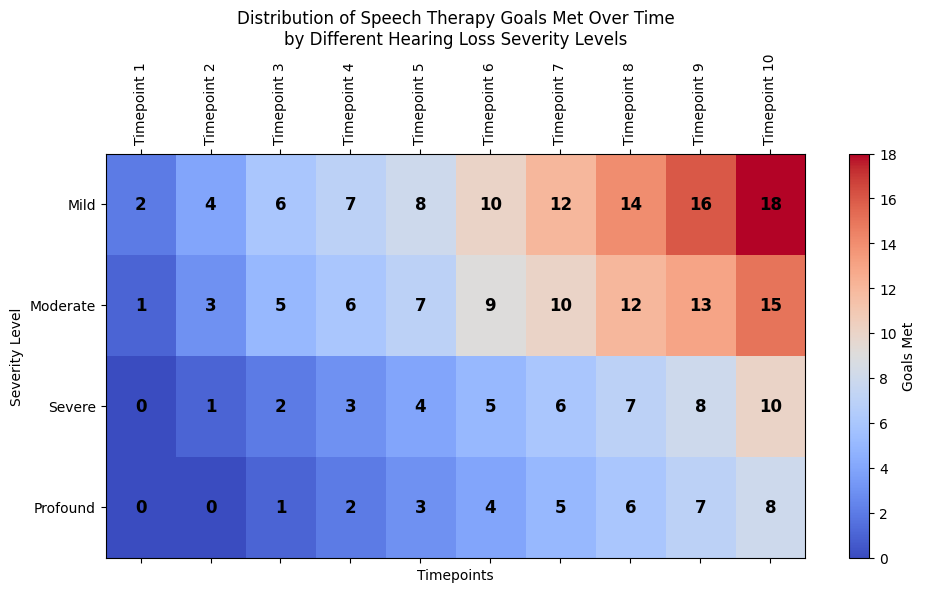What severity level has the most goals met at Timepoint 10? At Timepoint 10, checking the values for all severity levels shows Mild (18), Moderate (15), Severe (10), and Profound (8). Since 18 is the highest, Mild has the most goals met at Timepoint 10.
Answer: Mild Which severity level has the least goals met at Timepoint 3? For Timepoint 3, the values are Mild (6), Moderate (5), Severe (2), and Profound (1). Since 1 is the lowest, Profound has the least goals met at Timepoint 3.
Answer: Profound What is the average number of goals met by the Moderate severity level across all timepoints? Adding up the values for Moderate severity level: 1 + 3 + 5 + 6 + 7 + 9 + 10 + 12 + 13 + 15 = 81. The average is then 81 divided by 10 timepoints, which gives 81/10 = 8.1.
Answer: 8.1 How many more goals did the Mild severity level meet compared to the Severe level at Timepoint 6? At Timepoint 6, Mild met 10 goals and Severe met 5 goals. The difference is 10 - 5 = 5.
Answer: 5 Which severity levels have met the same number of goals at any timepoint, and what are those goals? At Timepoint 8 both Mild and Moderate have met 14 goals.
Answer: Mild and Moderate, 14 goals What is the total number of goals met by the Severe level over all timepoints? Adding up the values for Severe: 0 + 1 + 2 + 3 + 4 + 5 + 6 + 7 + 8 + 10 = 46.
Answer: 46 Which timepoint shows the highest number of goals met by any severity level, and which severity level achieved it? Timepoint 10 has the highest number of goals met by any severity level: Mild with 18 goals.
Answer: Timepoint 10, Mild By how much did the goals met by the Profound level increase from Timepoint 1 to Timepoint 10? Goals met by Profound level at Timepoint 1 is 0 and at Timepoint 10 is 8. The increase is 8 - 0 = 8.
Answer: 8 Are there any severity levels that showed no increase in goals met between consecutive timepoints, and if so, which timepoints? Checking the consecutive increments, all severity levels show some increase between each consecutive timepoint, so there are no instances of no increase.
Answer: No Which severity level shows the most consistent increase in goals met over all timepoints, and what is the trend? The Severe and Profound levels both show a consistent increase by 1 goal every timepoint, without any fluctuations.
Answer: Severe and Profound 